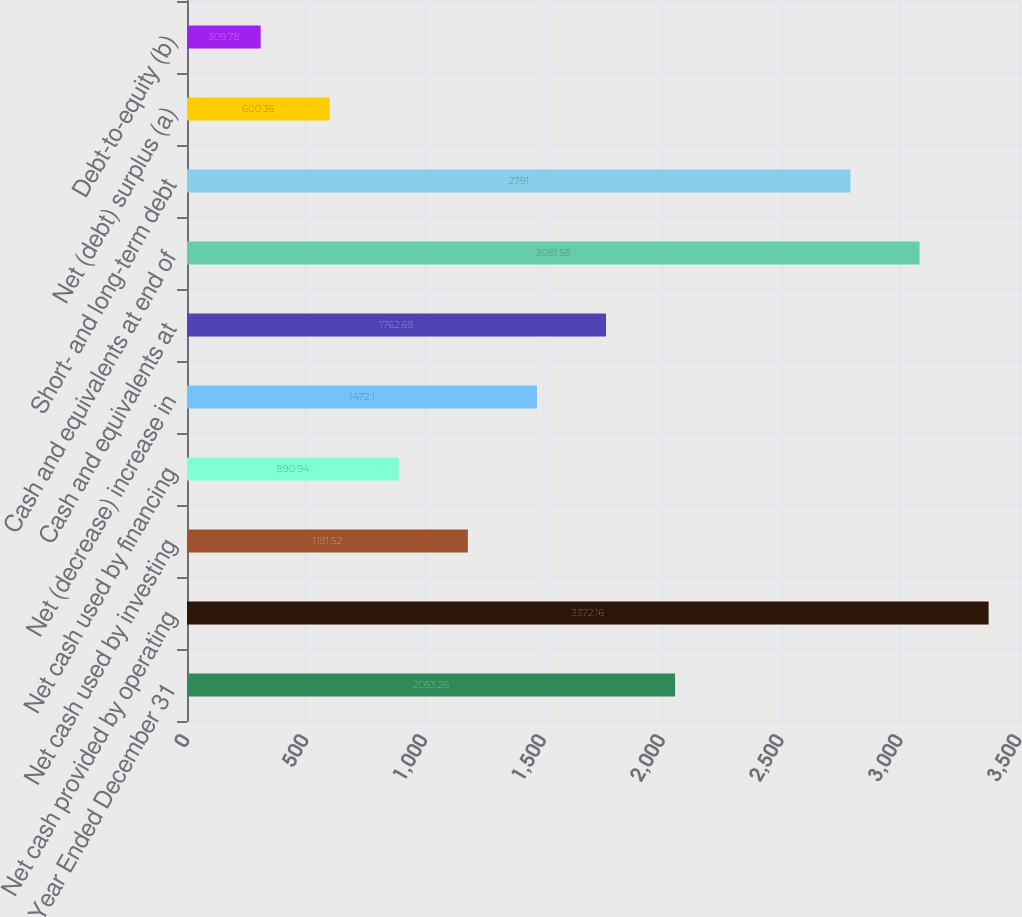<chart> <loc_0><loc_0><loc_500><loc_500><bar_chart><fcel>Year Ended December 31<fcel>Net cash provided by operating<fcel>Net cash used by investing<fcel>Net cash used by financing<fcel>Net (decrease) increase in<fcel>Cash and equivalents at<fcel>Cash and equivalents at end of<fcel>Short- and long-term debt<fcel>Net (debt) surplus (a)<fcel>Debt-to-equity (b)<nl><fcel>2053.26<fcel>3372.16<fcel>1181.52<fcel>890.94<fcel>1472.1<fcel>1762.68<fcel>3081.58<fcel>2791<fcel>600.36<fcel>309.78<nl></chart> 